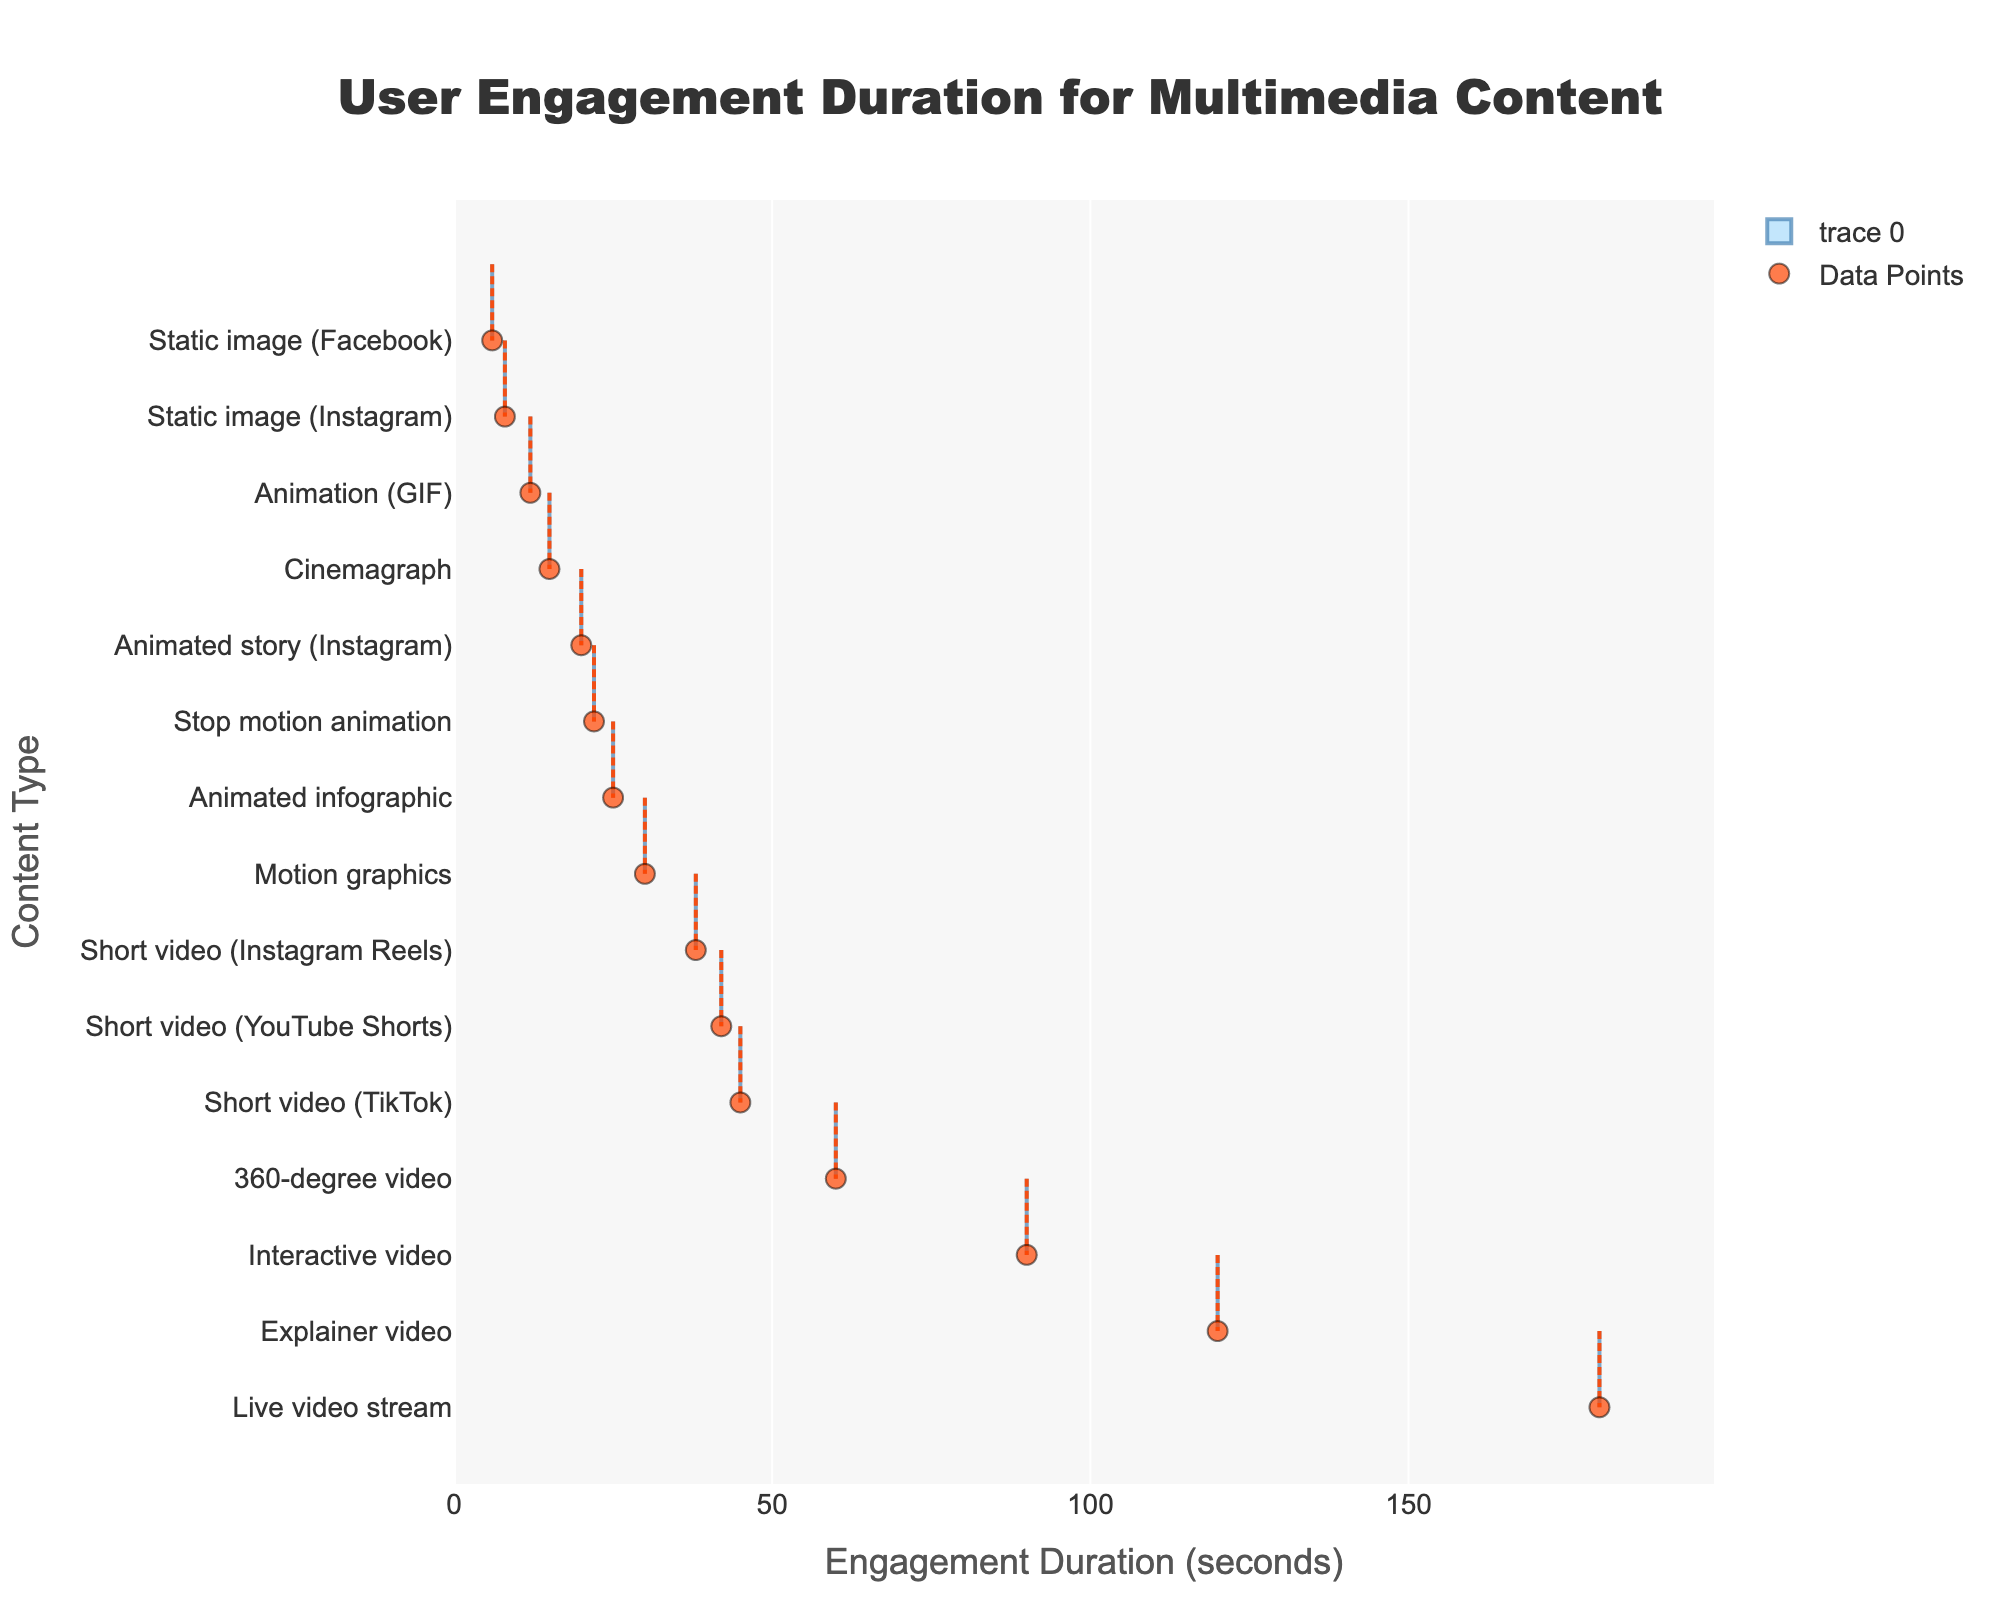What is the title of the figure? The title is prominently written at the top of the figure. By looking at the top center part of the chart, the title can be identified.
Answer: User Engagement Duration for Multimedia Content What is the longest engagement duration among the content types? The longest engagement bar represents the content type with the highest engagement duration. By scanning the figure, we identify the content type with the longest horizontal bar.
Answer: Live video stream How many types of multimedia content have an engagement duration of less than 20 seconds? By counting the horizontal bars that extend to a point less than 20 on the x-axis, we can identify how many content types meet this criterion.
Answer: 4 Which content type has the shortest engagement duration? The shortest engagement bar indicates the content type with the lowest engagement duration. By finding the shortest bar on the y-axis, we can determine the answer.
Answer: Static image (Facebook) What is the average engagement duration for Animated story (Instagram) and Motion graphics combined? To find the average, sum the engagement durations of Animated story (Instagram) and Motion graphics, then divide by 2. The durations for Animated story (Instagram) and Motion graphics are 20 and 30 seconds respectively. (20 + 30) / 2 = 25.
Answer: 25 Are short videos generally longer in engagement duration compared to static images? Compare the engagement durations of all short video types to all static image types. Short videos (45, 38, 42) have durations higher than static images (8, 6).
Answer: Yes Which content type has an engagement duration closest to 30 seconds? By looking at the x-axis around the 30-second mark, we can identify the content type whose bar ends closest to 30 seconds.
Answer: Motion graphics What is the difference in engagement duration between Static image (Instagram) and Animated infographic? Subtract the engagement duration of Static image (Instagram) from that of Animated infographic to find the difference. 25 - 8 = 17.
Answer: 17 Is the mean line for the engagement durations between any two specific content types visibly distinct? Visually, the mean line is clearly marked. Identify if the mean line is notably above or below the engagement durations of any specific content types.
Answer: Yes Between Stop motion animation and Cinemagraph, which has a longer engagement duration? Compare the horizontal lengths of the bars representing Stop motion animation and Cinemagraph. Stop motion animation has a longer bar (22 vs 15 seconds).
Answer: Stop motion animation 